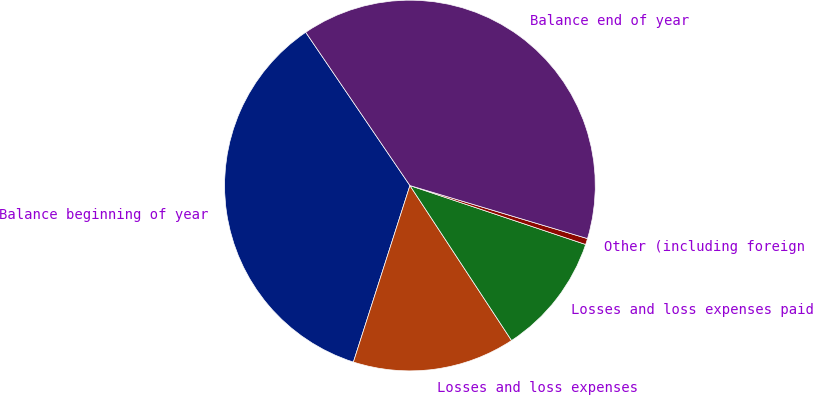Convert chart. <chart><loc_0><loc_0><loc_500><loc_500><pie_chart><fcel>Balance beginning of year<fcel>Losses and loss expenses<fcel>Losses and loss expenses paid<fcel>Other (including foreign<fcel>Balance end of year<nl><fcel>35.56%<fcel>14.17%<fcel>10.61%<fcel>0.53%<fcel>39.12%<nl></chart> 